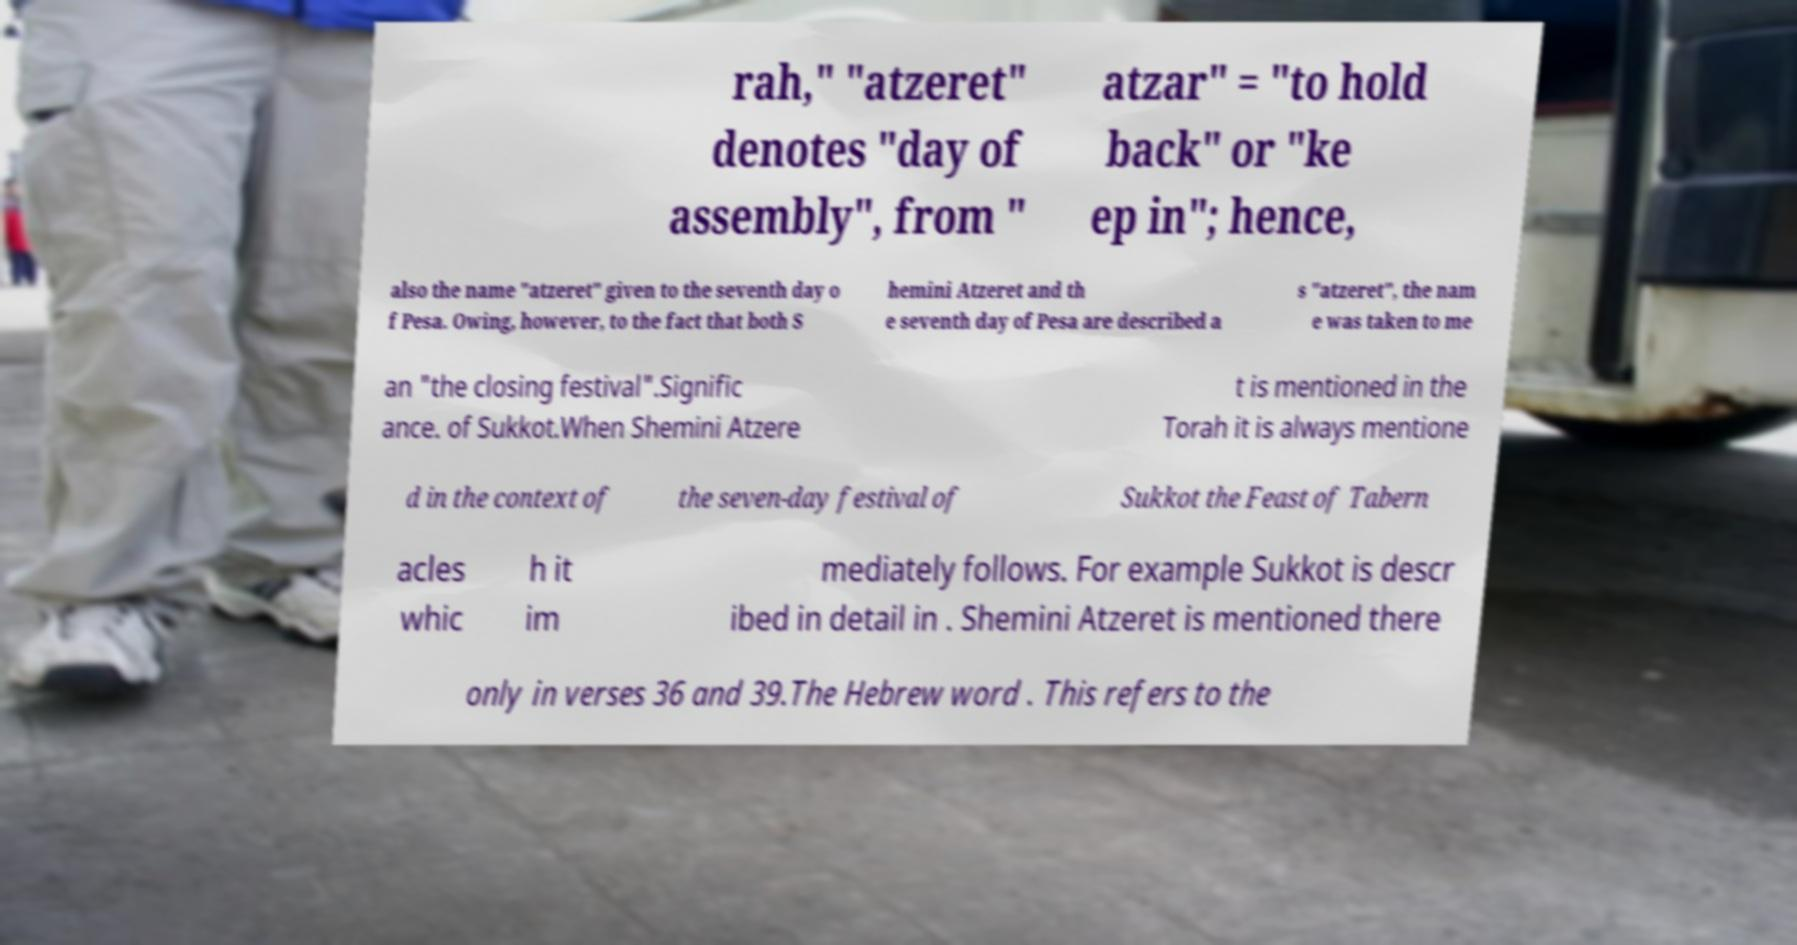Please identify and transcribe the text found in this image. rah," "atzeret" denotes "day of assembly", from " atzar" = "to hold back" or "ke ep in"; hence, also the name "atzeret" given to the seventh day o f Pesa. Owing, however, to the fact that both S hemini Atzeret and th e seventh day of Pesa are described a s "atzeret", the nam e was taken to me an "the closing festival".Signific ance. of Sukkot.When Shemini Atzere t is mentioned in the Torah it is always mentione d in the context of the seven-day festival of Sukkot the Feast of Tabern acles whic h it im mediately follows. For example Sukkot is descr ibed in detail in . Shemini Atzeret is mentioned there only in verses 36 and 39.The Hebrew word . This refers to the 